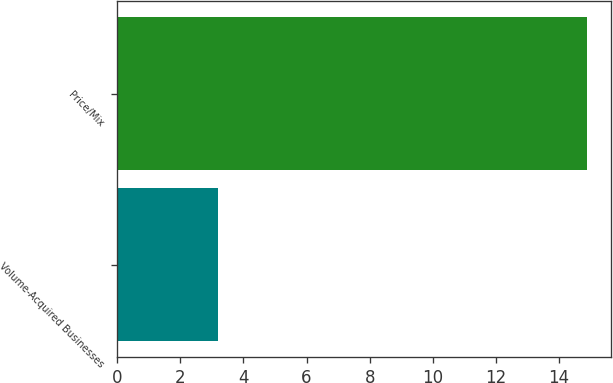<chart> <loc_0><loc_0><loc_500><loc_500><bar_chart><fcel>Volume-Acquired Businesses<fcel>Price/Mix<nl><fcel>3.2<fcel>14.9<nl></chart> 